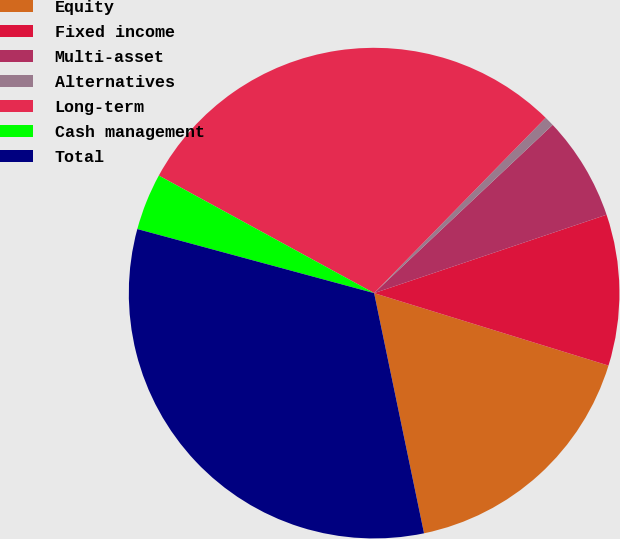Convert chart to OTSL. <chart><loc_0><loc_0><loc_500><loc_500><pie_chart><fcel>Equity<fcel>Fixed income<fcel>Multi-asset<fcel>Alternatives<fcel>Long-term<fcel>Cash management<fcel>Total<nl><fcel>16.97%<fcel>9.95%<fcel>6.85%<fcel>0.65%<fcel>29.37%<fcel>3.75%<fcel>32.47%<nl></chart> 